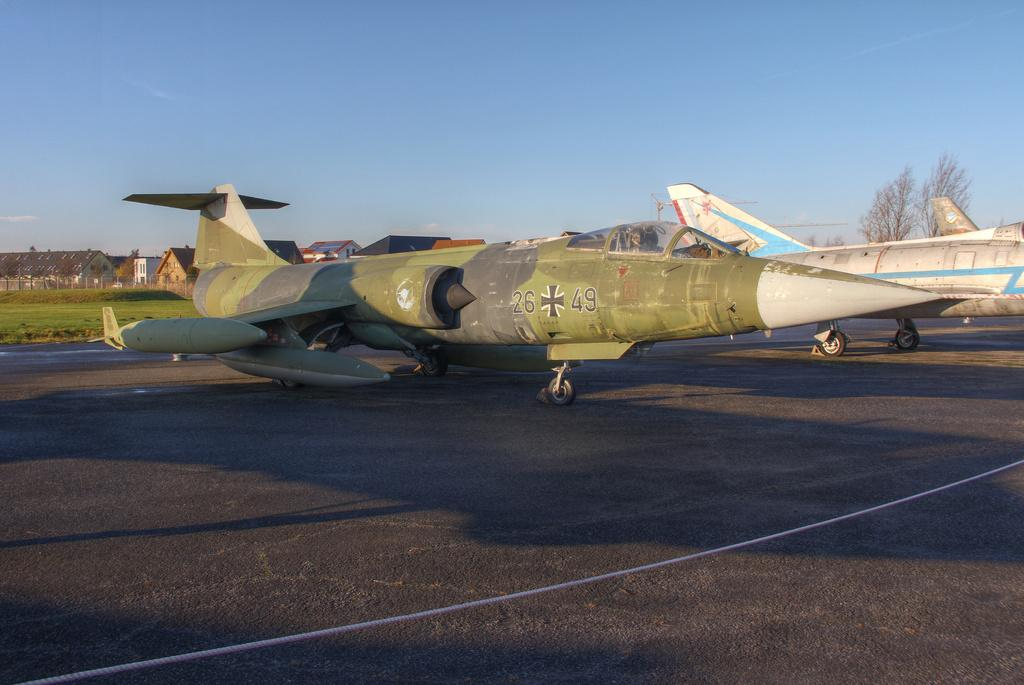<image>
Relay a brief, clear account of the picture shown. A camouflage plane parked on an airstrip which has the letters 26 and 49. 